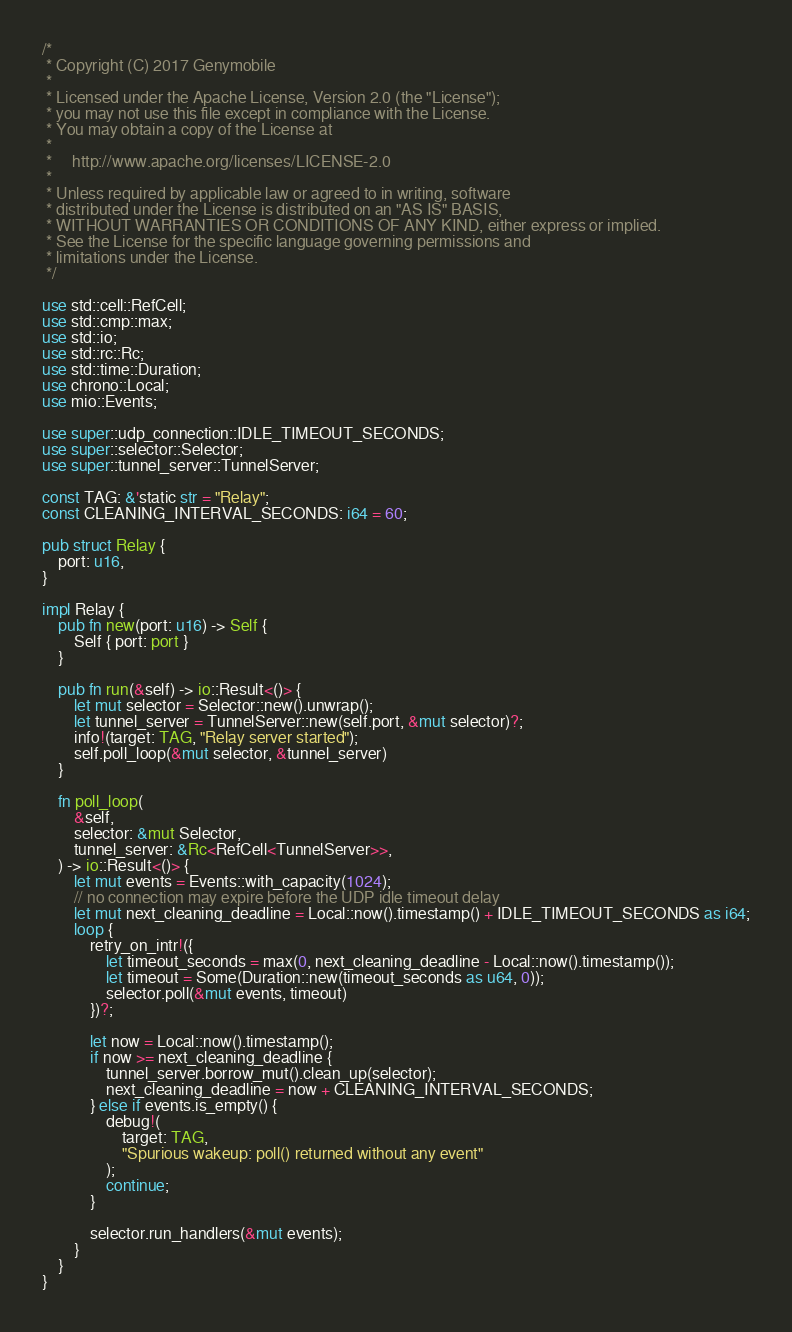Convert code to text. <code><loc_0><loc_0><loc_500><loc_500><_Rust_>/*
 * Copyright (C) 2017 Genymobile
 *
 * Licensed under the Apache License, Version 2.0 (the "License");
 * you may not use this file except in compliance with the License.
 * You may obtain a copy of the License at
 *
 *     http://www.apache.org/licenses/LICENSE-2.0
 *
 * Unless required by applicable law or agreed to in writing, software
 * distributed under the License is distributed on an "AS IS" BASIS,
 * WITHOUT WARRANTIES OR CONDITIONS OF ANY KIND, either express or implied.
 * See the License for the specific language governing permissions and
 * limitations under the License.
 */

use std::cell::RefCell;
use std::cmp::max;
use std::io;
use std::rc::Rc;
use std::time::Duration;
use chrono::Local;
use mio::Events;

use super::udp_connection::IDLE_TIMEOUT_SECONDS;
use super::selector::Selector;
use super::tunnel_server::TunnelServer;

const TAG: &'static str = "Relay";
const CLEANING_INTERVAL_SECONDS: i64 = 60;

pub struct Relay {
    port: u16,
}

impl Relay {
    pub fn new(port: u16) -> Self {
        Self { port: port }
    }

    pub fn run(&self) -> io::Result<()> {
        let mut selector = Selector::new().unwrap();
        let tunnel_server = TunnelServer::new(self.port, &mut selector)?;
        info!(target: TAG, "Relay server started");
        self.poll_loop(&mut selector, &tunnel_server)
    }

    fn poll_loop(
        &self,
        selector: &mut Selector,
        tunnel_server: &Rc<RefCell<TunnelServer>>,
    ) -> io::Result<()> {
        let mut events = Events::with_capacity(1024);
        // no connection may expire before the UDP idle timeout delay
        let mut next_cleaning_deadline = Local::now().timestamp() + IDLE_TIMEOUT_SECONDS as i64;
        loop {
            retry_on_intr!({
                let timeout_seconds = max(0, next_cleaning_deadline - Local::now().timestamp());
                let timeout = Some(Duration::new(timeout_seconds as u64, 0));
                selector.poll(&mut events, timeout)
            })?;

            let now = Local::now().timestamp();
            if now >= next_cleaning_deadline {
                tunnel_server.borrow_mut().clean_up(selector);
                next_cleaning_deadline = now + CLEANING_INTERVAL_SECONDS;
            } else if events.is_empty() {
                debug!(
                    target: TAG,
                    "Spurious wakeup: poll() returned without any event"
                );
                continue;
            }

            selector.run_handlers(&mut events);
        }
    }
}
</code> 